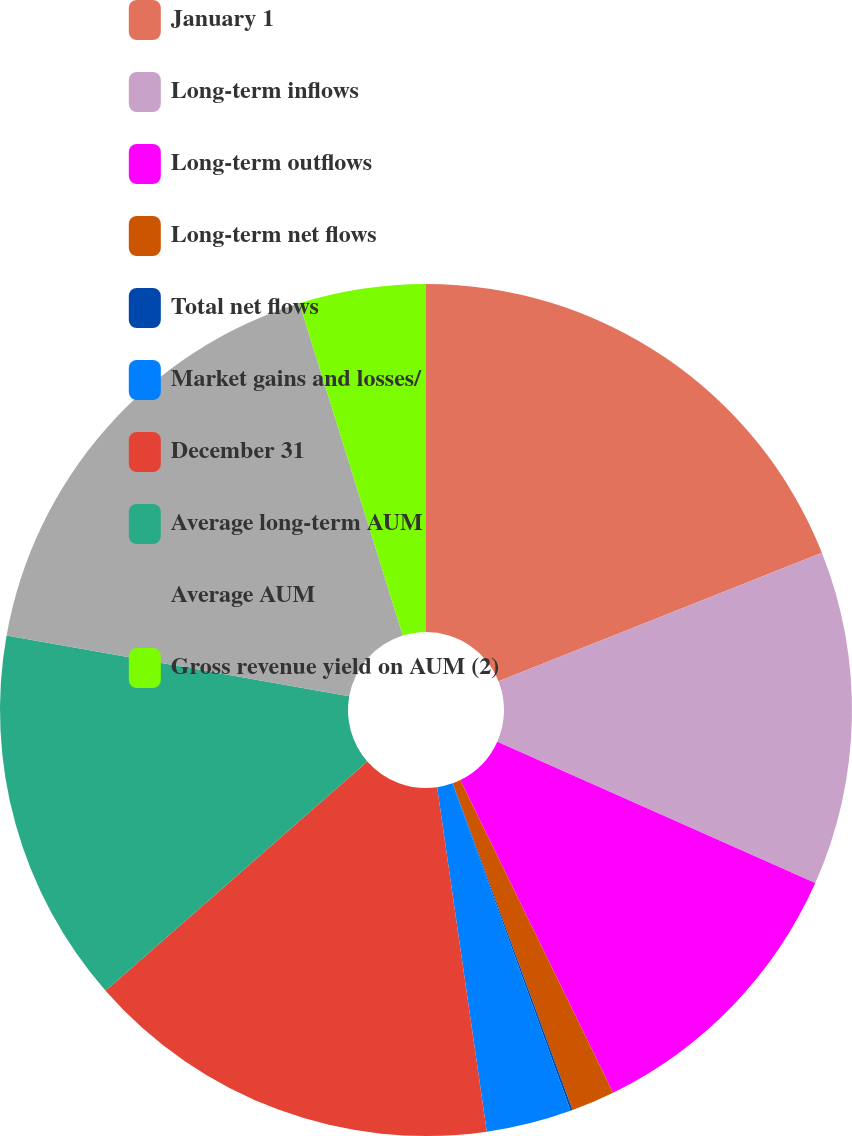Convert chart to OTSL. <chart><loc_0><loc_0><loc_500><loc_500><pie_chart><fcel>January 1<fcel>Long-term inflows<fcel>Long-term outflows<fcel>Long-term net flows<fcel>Total net flows<fcel>Market gains and losses/<fcel>December 31<fcel>Average long-term AUM<fcel>Average AUM<fcel>Gross revenue yield on AUM (2)<nl><fcel>18.98%<fcel>12.68%<fcel>11.1%<fcel>1.65%<fcel>0.08%<fcel>3.23%<fcel>15.83%<fcel>14.25%<fcel>17.4%<fcel>4.8%<nl></chart> 